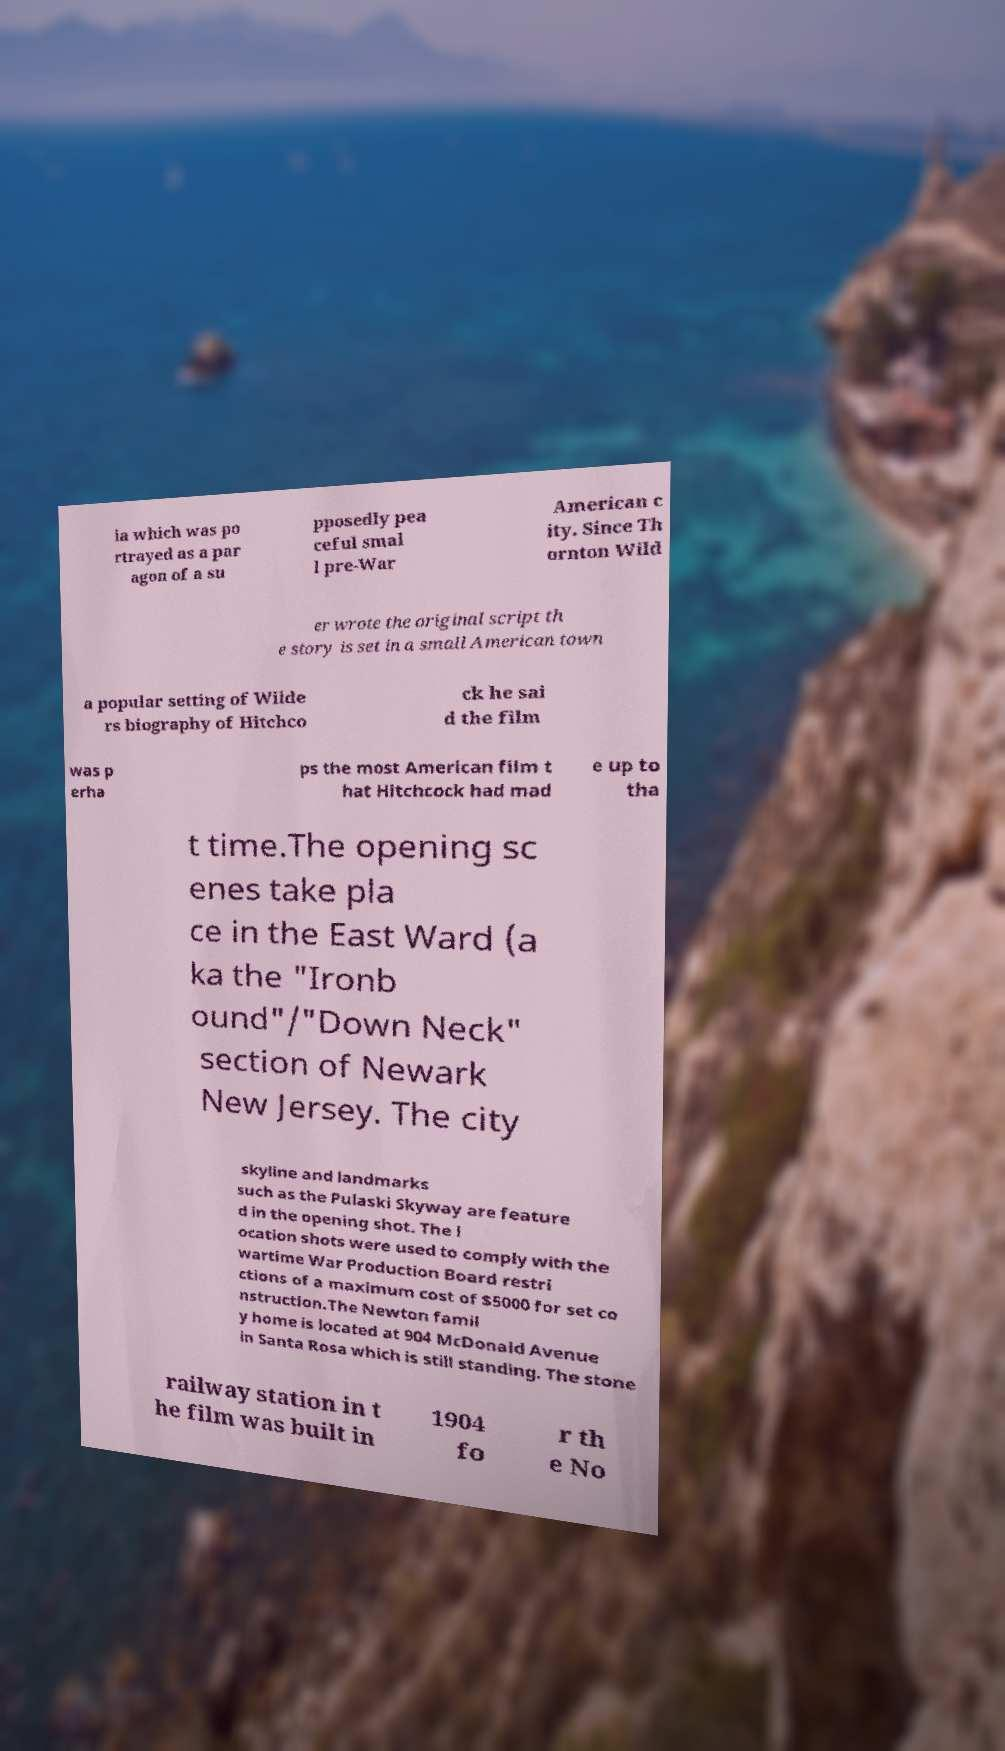I need the written content from this picture converted into text. Can you do that? ia which was po rtrayed as a par agon of a su pposedly pea ceful smal l pre-War American c ity. Since Th ornton Wild er wrote the original script th e story is set in a small American town a popular setting of Wilde rs biography of Hitchco ck he sai d the film was p erha ps the most American film t hat Hitchcock had mad e up to tha t time.The opening sc enes take pla ce in the East Ward (a ka the "Ironb ound"/"Down Neck" section of Newark New Jersey. The city skyline and landmarks such as the Pulaski Skyway are feature d in the opening shot. The l ocation shots were used to comply with the wartime War Production Board restri ctions of a maximum cost of $5000 for set co nstruction.The Newton famil y home is located at 904 McDonald Avenue in Santa Rosa which is still standing. The stone railway station in t he film was built in 1904 fo r th e No 